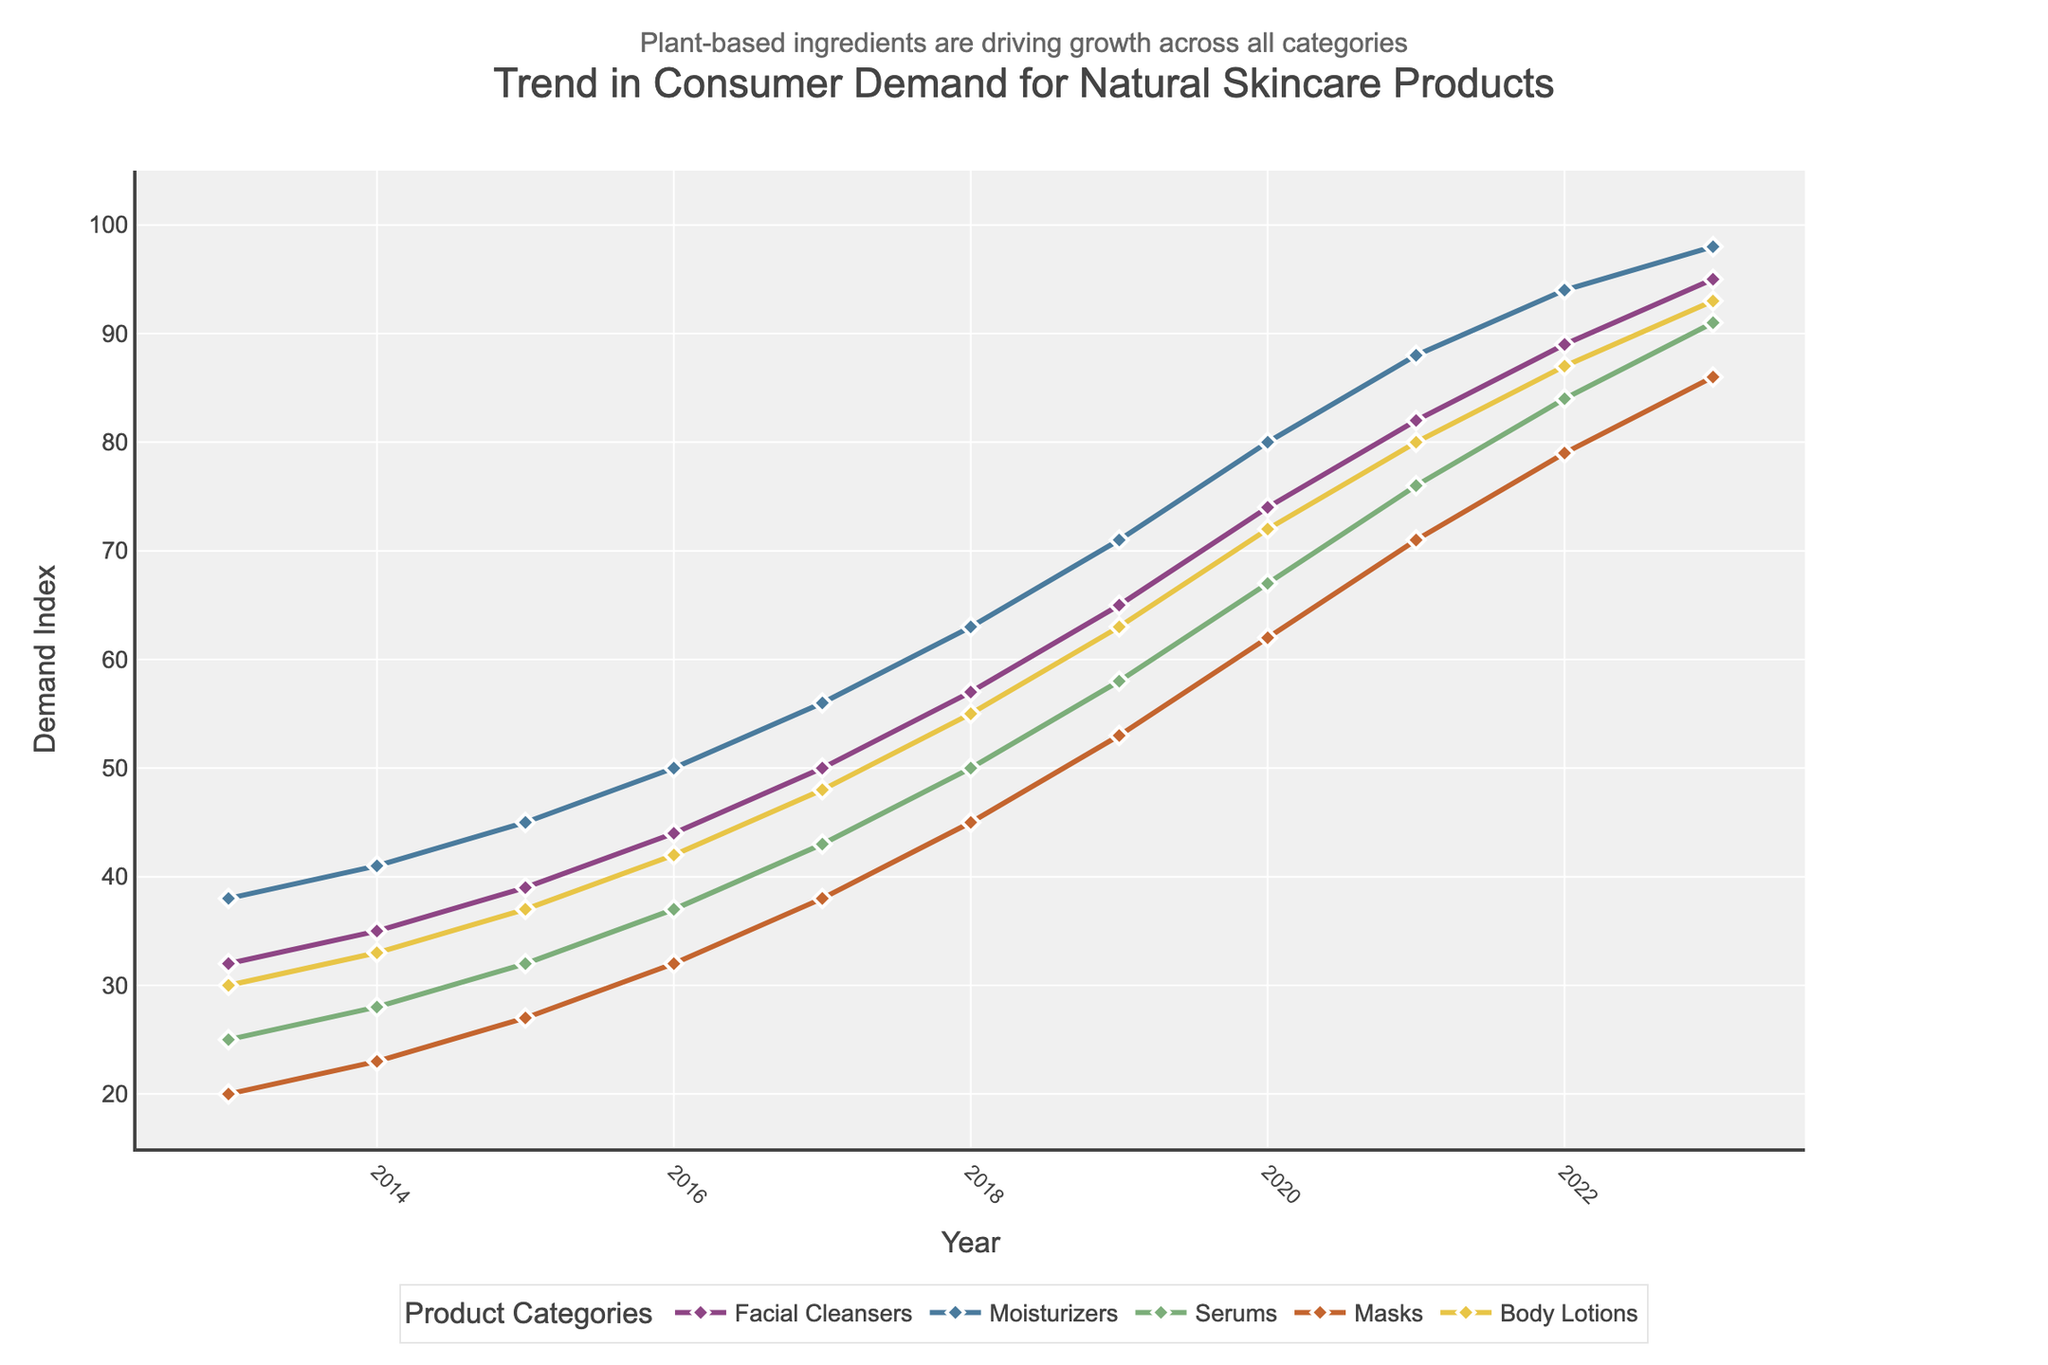What is the trend in consumer demand for natural skincare products from 2013 to 2023? The trend shows a steady increase in demand across all product categories over the past decade. Each year, the demand index has consistently risen for facial cleansers, moisturizers, serums, masks, and body lotions.
Answer: Steady increase Which product category showed the highest demand in 2023? In 2023, the product category with the highest demand is moisturizers, with a demand index of 98.
Answer: Moisturizers How does the demand for facial cleansers in 2023 compare to its demand in 2013? To compare the demand, subtract the 2013 value from the 2023 value: 95 (2023) - 32 (2013). The demand for facial cleansers increased by 63 from 2013 to 2023.
Answer: Increased by 63 Which two categories have the smallest difference in demand in 2023? To determine this, look at the 2023 values: Facial Cleansers (95), Moisturizers (98), Serums (91), Masks (86), Body Lotions (93). The smallest difference is between Serums (91) and Body Lotions (93), with a difference of 2.
Answer: Serums and Body Lotions What color is used to represent serums in the grid? The color representing serums in the chart is green. This can be seen by matching the color of the lines and markers with the legend.
Answer: Green On average, how much does the demand for masks increase each year from 2013 to 2023? To find the average yearly increase, use the values for masks: (86 - 20) / 10. The total increase is 66, so the average yearly increase is 66 / 10 = 6.6.
Answer: 6.6 What is the relative demand for body lotions in 2019 compared to serums in the same year? For 2019, the demand for body lotions is 63, while the demand for serums is 58. The demand for body lotions is 5 units higher than for serums in 2019.
Answer: 5 units higher How do the growth rates of moisturizers and facial cleansers compare between 2013 and 2023? Calculate the growth rates using the formula (2023 value - 2013 value) / 2013 value * 100%. For moisturizers: (98-38)/38*100 ≈ 157.9%. For facial cleansers: (95-32)/32*100 ≈ 196.9%. Thus, facial cleansers grew by approximately 196.9%, and moisturizers by 157.9%.
Answer: Facial cleansers grew more Between which years did the demand for body lotions see the steepest increase? Look at the differences between consecutive years for body lotions: 2013-2014 (30-33=3), 2014-2015 (33-37=4), etc., the steepest increase is from 2018 to 2019, where the demand increased from 55 to 63.
Answer: 2018-2019 